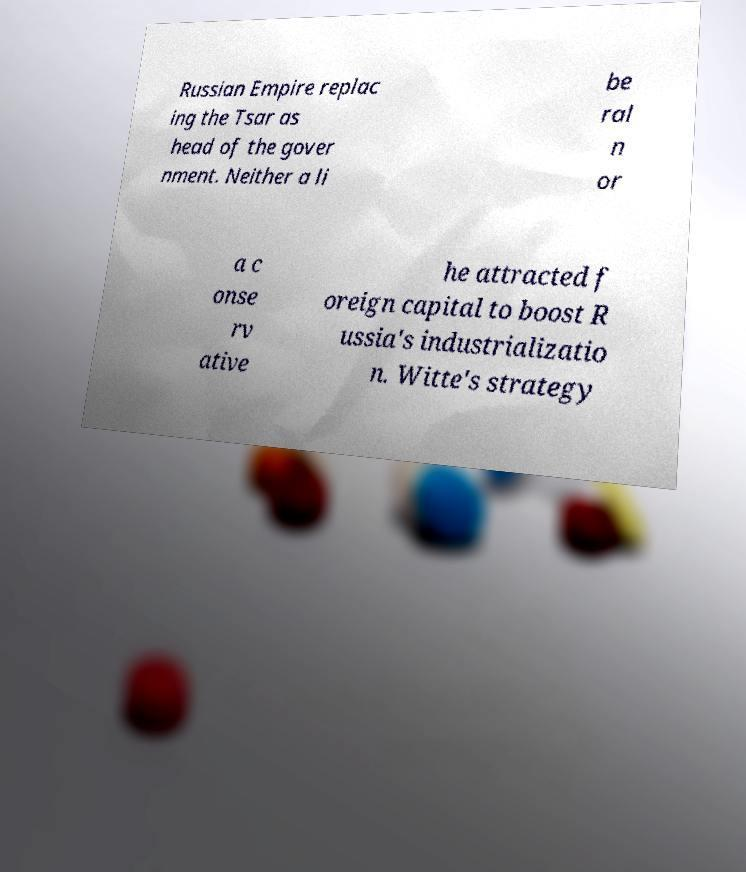I need the written content from this picture converted into text. Can you do that? Russian Empire replac ing the Tsar as head of the gover nment. Neither a li be ral n or a c onse rv ative he attracted f oreign capital to boost R ussia's industrializatio n. Witte's strategy 